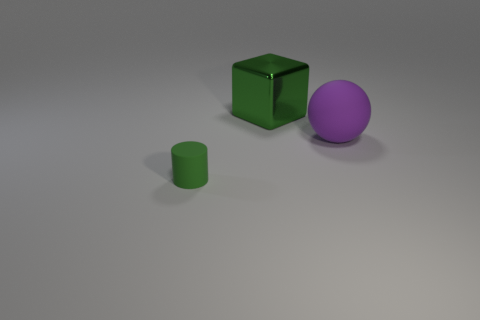Add 2 big gray cylinders. How many objects exist? 5 Subtract all cubes. How many objects are left? 2 Add 3 large purple matte things. How many large purple matte things are left? 4 Add 1 large green metallic balls. How many large green metallic balls exist? 1 Subtract 0 red blocks. How many objects are left? 3 Subtract all cyan spheres. Subtract all large green objects. How many objects are left? 2 